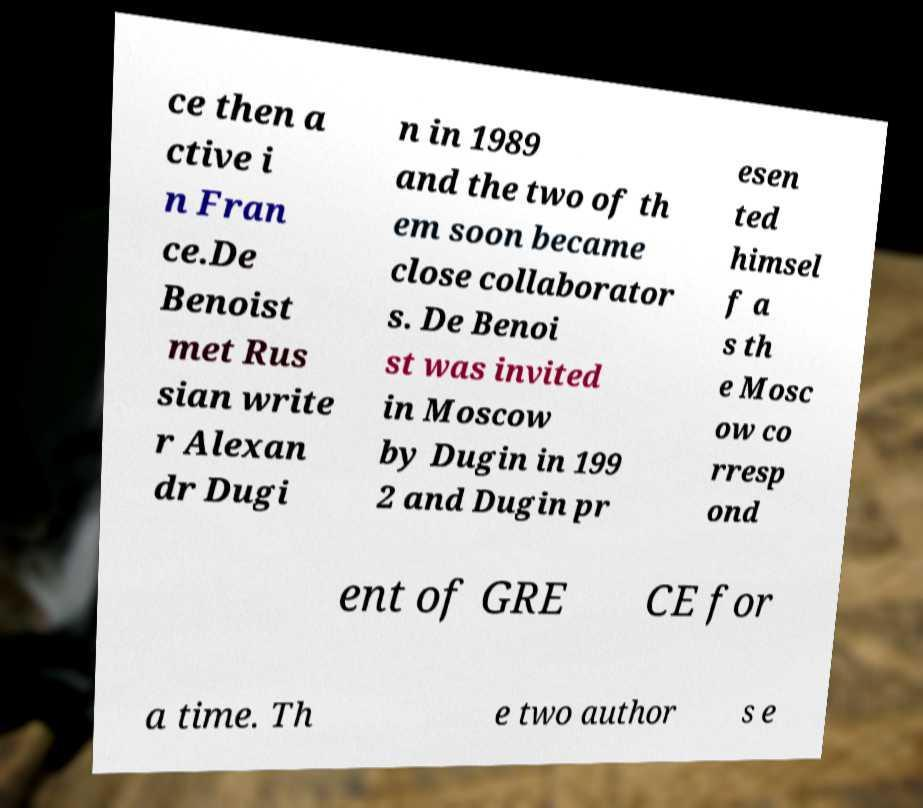Could you extract and type out the text from this image? ce then a ctive i n Fran ce.De Benoist met Rus sian write r Alexan dr Dugi n in 1989 and the two of th em soon became close collaborator s. De Benoi st was invited in Moscow by Dugin in 199 2 and Dugin pr esen ted himsel f a s th e Mosc ow co rresp ond ent of GRE CE for a time. Th e two author s e 